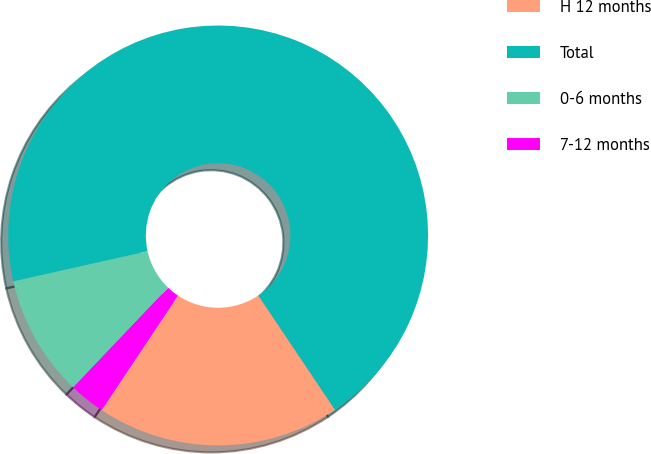<chart> <loc_0><loc_0><loc_500><loc_500><pie_chart><fcel>H 12 months<fcel>Total<fcel>0-6 months<fcel>7-12 months<nl><fcel>18.76%<fcel>69.11%<fcel>9.38%<fcel>2.75%<nl></chart> 